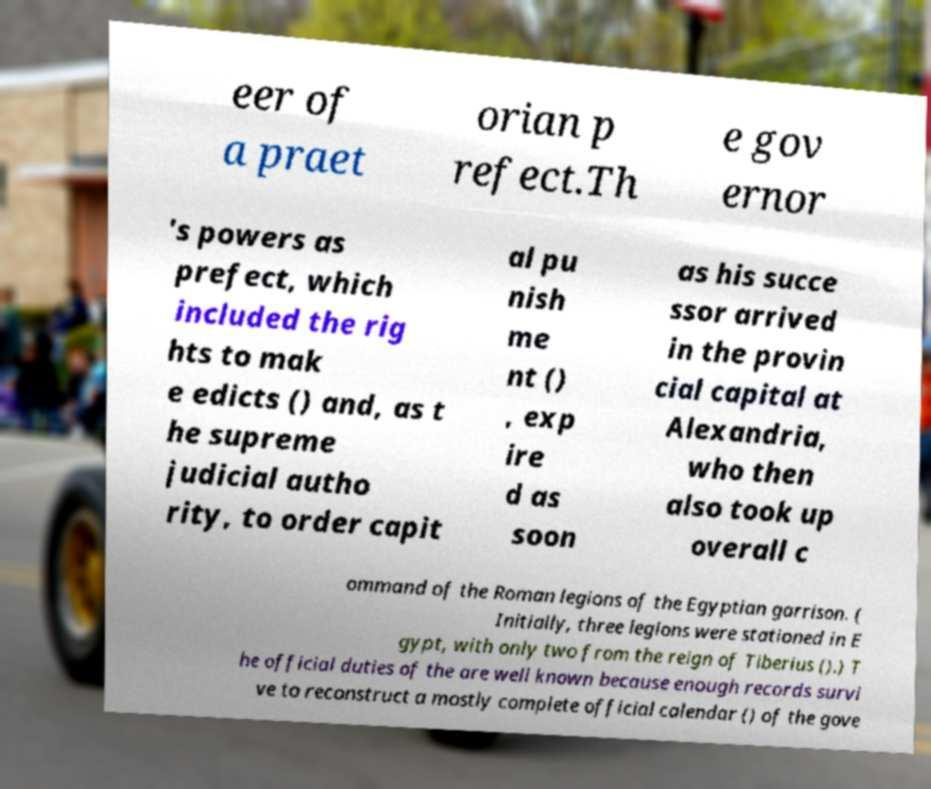What messages or text are displayed in this image? I need them in a readable, typed format. eer of a praet orian p refect.Th e gov ernor 's powers as prefect, which included the rig hts to mak e edicts () and, as t he supreme judicial autho rity, to order capit al pu nish me nt () , exp ire d as soon as his succe ssor arrived in the provin cial capital at Alexandria, who then also took up overall c ommand of the Roman legions of the Egyptian garrison. ( Initially, three legions were stationed in E gypt, with only two from the reign of Tiberius ().) T he official duties of the are well known because enough records survi ve to reconstruct a mostly complete official calendar () of the gove 